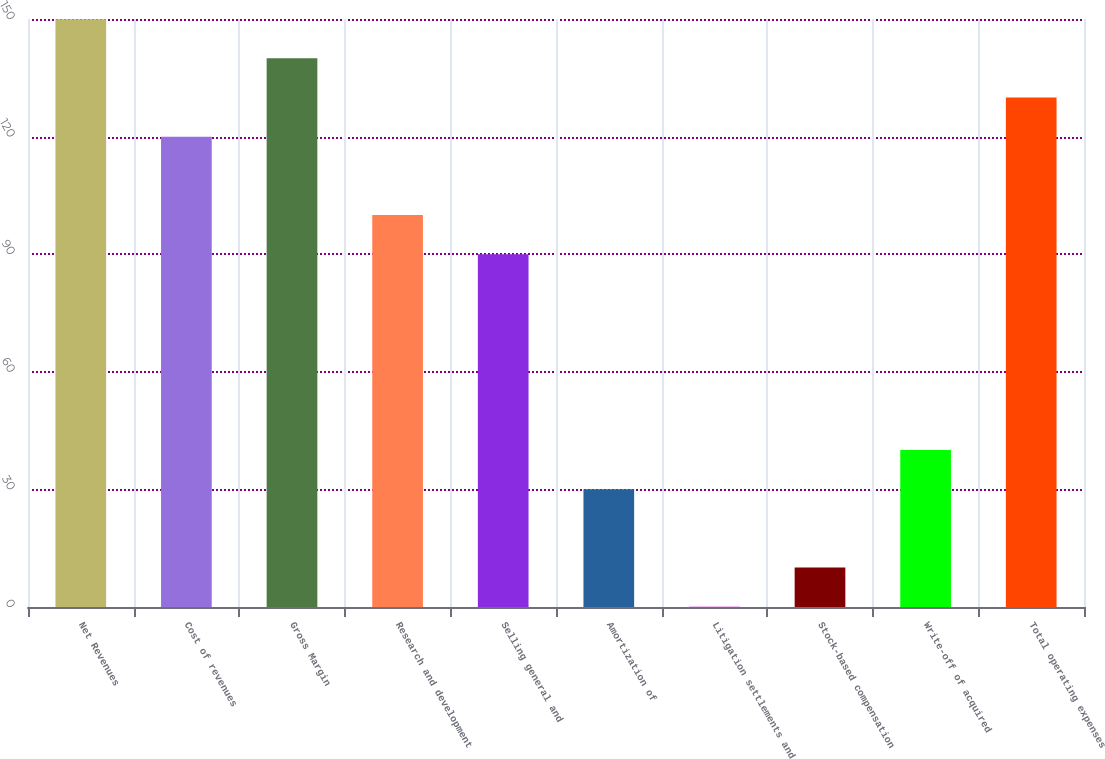Convert chart to OTSL. <chart><loc_0><loc_0><loc_500><loc_500><bar_chart><fcel>Net Revenues<fcel>Cost of revenues<fcel>Gross Margin<fcel>Research and development<fcel>Selling general and<fcel>Amortization of<fcel>Litigation settlements and<fcel>Stock-based compensation<fcel>Write-off of acquired<fcel>Total operating expenses<nl><fcel>149.95<fcel>119.98<fcel>139.96<fcel>100<fcel>90.01<fcel>30.07<fcel>0.1<fcel>10.09<fcel>40.06<fcel>129.97<nl></chart> 